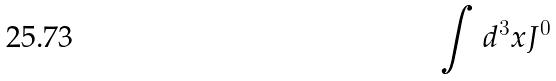Convert formula to latex. <formula><loc_0><loc_0><loc_500><loc_500>\int d ^ { 3 } x J ^ { 0 }</formula> 